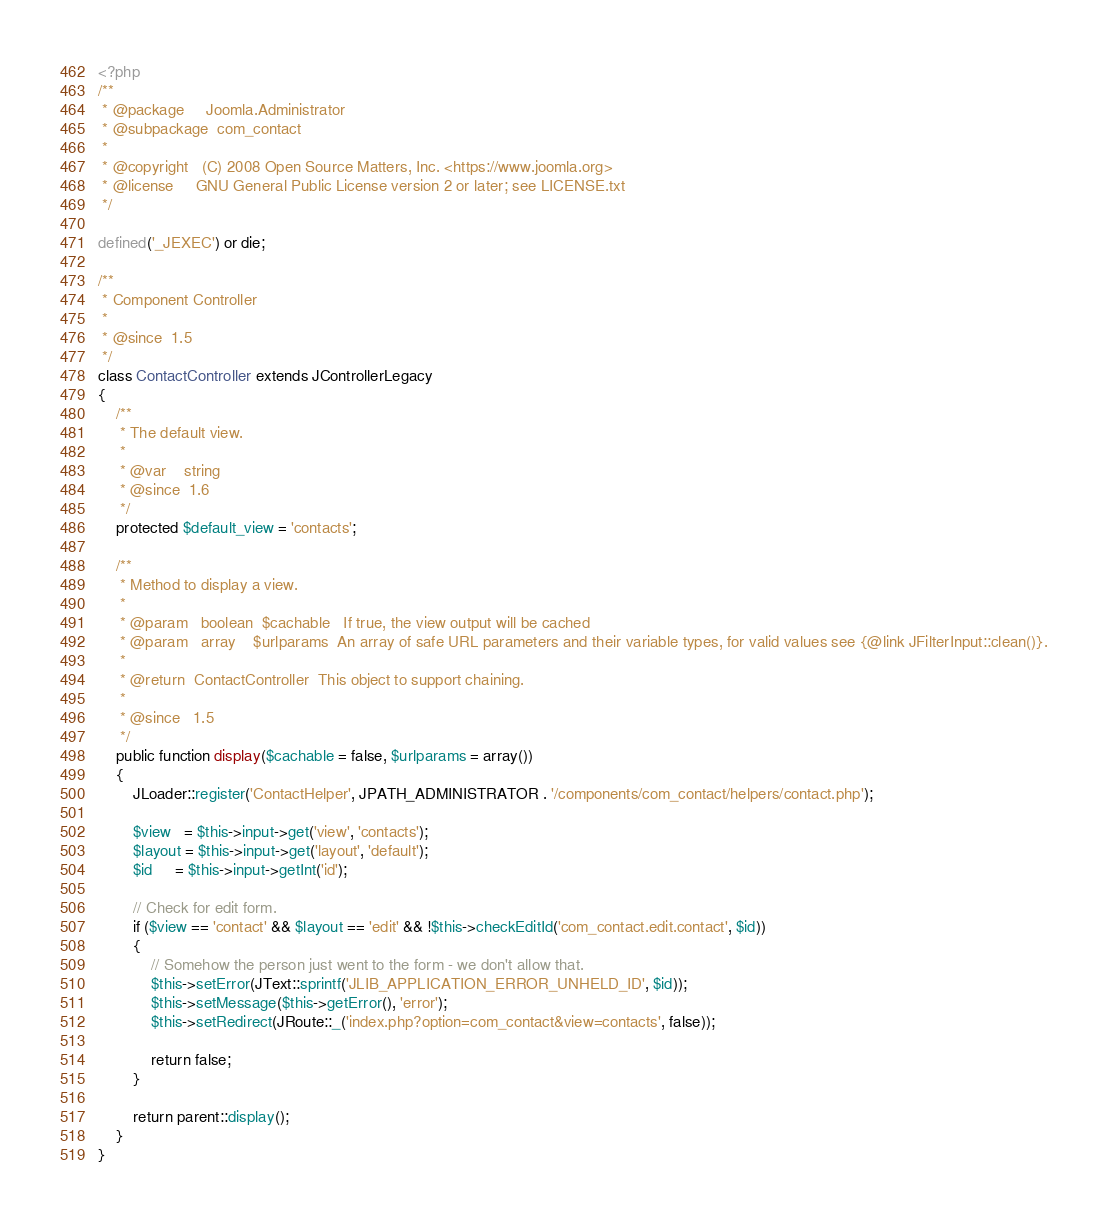<code> <loc_0><loc_0><loc_500><loc_500><_PHP_><?php
/**
 * @package     Joomla.Administrator
 * @subpackage  com_contact
 *
 * @copyright   (C) 2008 Open Source Matters, Inc. <https://www.joomla.org>
 * @license     GNU General Public License version 2 or later; see LICENSE.txt
 */

defined('_JEXEC') or die;

/**
 * Component Controller
 *
 * @since  1.5
 */
class ContactController extends JControllerLegacy
{
	/**
	 * The default view.
	 *
	 * @var    string
	 * @since  1.6
	 */
	protected $default_view = 'contacts';

	/**
	 * Method to display a view.
	 *
	 * @param   boolean  $cachable   If true, the view output will be cached
	 * @param   array    $urlparams  An array of safe URL parameters and their variable types, for valid values see {@link JFilterInput::clean()}.
	 *
	 * @return  ContactController  This object to support chaining.
	 *
	 * @since   1.5
	 */
	public function display($cachable = false, $urlparams = array())
	{
		JLoader::register('ContactHelper', JPATH_ADMINISTRATOR . '/components/com_contact/helpers/contact.php');

		$view   = $this->input->get('view', 'contacts');
		$layout = $this->input->get('layout', 'default');
		$id     = $this->input->getInt('id');

		// Check for edit form.
		if ($view == 'contact' && $layout == 'edit' && !$this->checkEditId('com_contact.edit.contact', $id))
		{
			// Somehow the person just went to the form - we don't allow that.
			$this->setError(JText::sprintf('JLIB_APPLICATION_ERROR_UNHELD_ID', $id));
			$this->setMessage($this->getError(), 'error');
			$this->setRedirect(JRoute::_('index.php?option=com_contact&view=contacts', false));

			return false;
		}

		return parent::display();
	}
}
</code> 